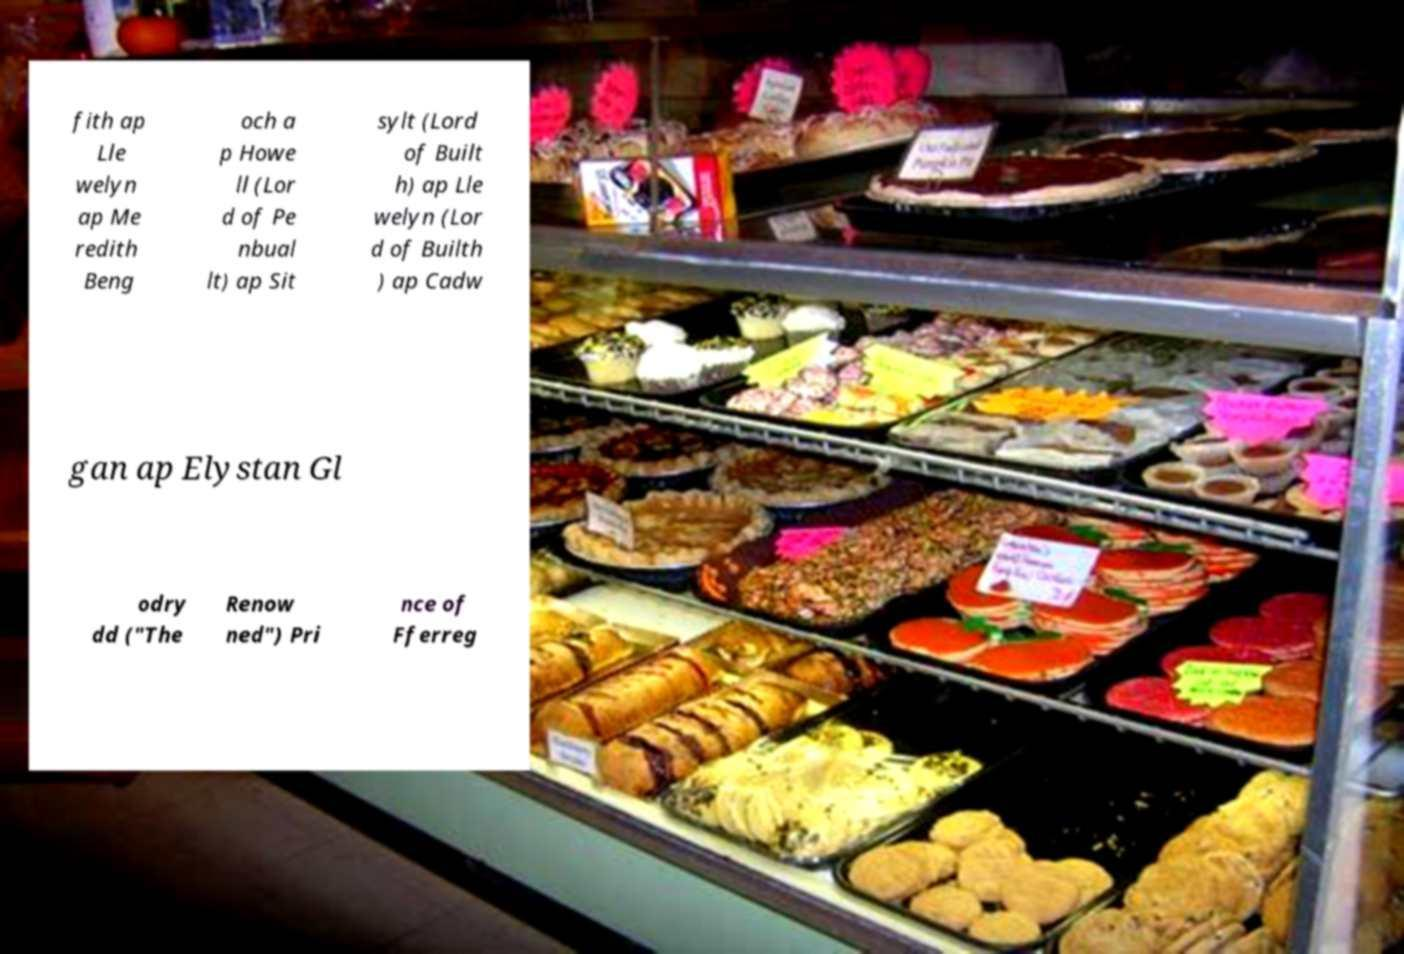Can you accurately transcribe the text from the provided image for me? fith ap Lle welyn ap Me redith Beng och a p Howe ll (Lor d of Pe nbual lt) ap Sit sylt (Lord of Built h) ap Lle welyn (Lor d of Builth ) ap Cadw gan ap Elystan Gl odry dd ("The Renow ned") Pri nce of Fferreg 